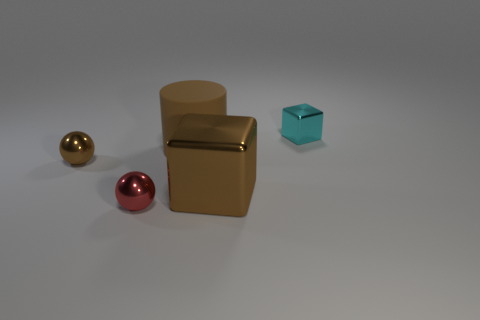Is there anything else that is the same shape as the rubber object?
Provide a short and direct response. No. What material is the cyan thing that is the same size as the red shiny ball?
Ensure brevity in your answer.  Metal. What is the shape of the small brown thing?
Provide a short and direct response. Sphere. How many purple objects are either big objects or shiny things?
Your response must be concise. 0. There is a red sphere that is the same material as the brown ball; what is its size?
Your answer should be very brief. Small. Is the material of the block in front of the tiny shiny cube the same as the big thing that is behind the small brown metal ball?
Ensure brevity in your answer.  No. What number of blocks are either cyan shiny things or small things?
Your answer should be compact. 1. How many big cylinders are on the right side of the small thing on the right side of the metallic cube that is in front of the small brown object?
Your response must be concise. 0. What material is the other thing that is the same shape as the small red metallic thing?
Provide a succinct answer. Metal. Is there anything else that has the same material as the large brown cylinder?
Give a very brief answer. No. 